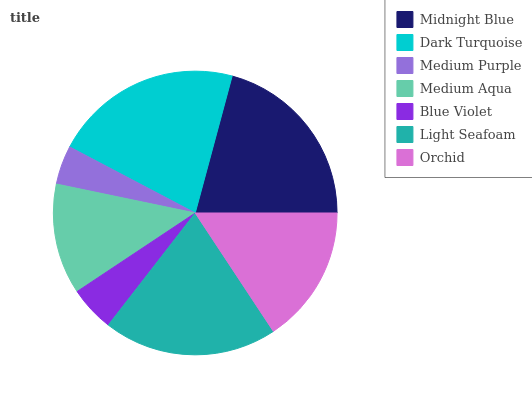Is Medium Purple the minimum?
Answer yes or no. Yes. Is Dark Turquoise the maximum?
Answer yes or no. Yes. Is Dark Turquoise the minimum?
Answer yes or no. No. Is Medium Purple the maximum?
Answer yes or no. No. Is Dark Turquoise greater than Medium Purple?
Answer yes or no. Yes. Is Medium Purple less than Dark Turquoise?
Answer yes or no. Yes. Is Medium Purple greater than Dark Turquoise?
Answer yes or no. No. Is Dark Turquoise less than Medium Purple?
Answer yes or no. No. Is Orchid the high median?
Answer yes or no. Yes. Is Orchid the low median?
Answer yes or no. Yes. Is Medium Aqua the high median?
Answer yes or no. No. Is Blue Violet the low median?
Answer yes or no. No. 